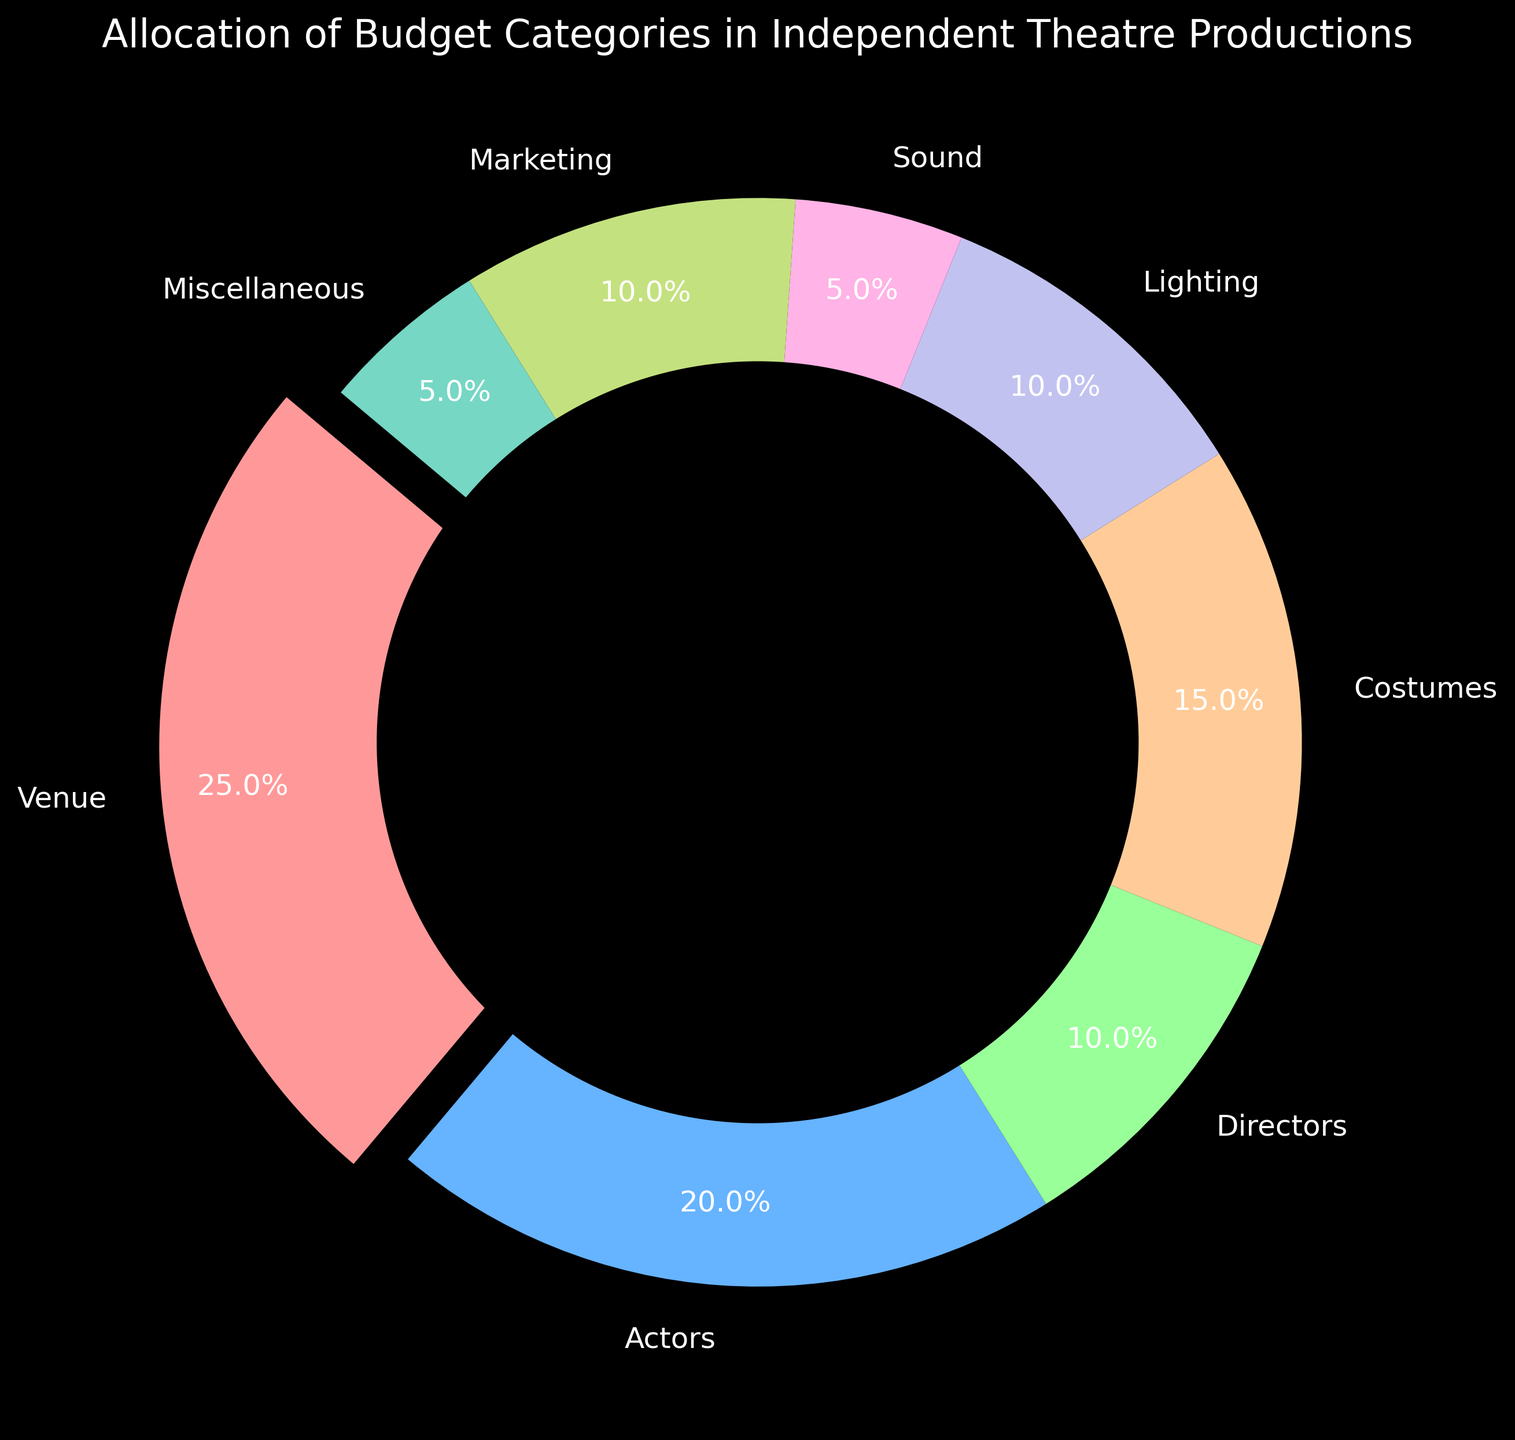What is the category with the largest budget allocation? The category with the largest budget allocation is visually emphasized by being slightly exploded out from the center. Looking at the chart, "Venue" is the most prominent category with 25%.
Answer: Venue Which two categories have a combined budget allocation of 30%? To find the combined budget allocation, sum the percentages of different categories. The categories "Directors" (10%) and "Marketing" (10%) together with "Sound" (5%) and "Miscellaneous" (5%) both total 30%.
Answer: Directors and Marketing; or Sound and Miscellaneous How does the budget allocation for Lighting compare to that for Costumes? Looking at the chart, "Lighting" has a 10% allocation, while "Costumes" has a 15% allocation.
Answer: Lighting has a smaller budget than Costumes How much more budget is allocated to Venue than Actors? The "Venue" category has 25%, while "Actors" has 20%. The difference is 25% - 20%.
Answer: 5% If you combine the budget for Lighting and Sound, does it exceed the budget for Costumes? Lighting has 10% and Sound has 5%, so combined, they total 15%. Costumes also have 15%. Therefore, the combined budget for Lighting and Sound equals that for Costumes.
Answer: No What is the average budget allocation for Actors, Costumes, and Marketing? To find the average, sum the allocations and divide by the number of categories. Actors: 20%, Costumes: 15%, Marketing: 10%. Sum is 45%. Divide by 3 to get the average (45% / 3).
Answer: 15% Which category has the smallest budget allocation, and what is its percentage? By visually identifying the smallest segment in the chart, the "Sound" and "Miscellaneous" categories are the smallest, both having 5% each.
Answer: Sound and Miscellaneous, 5% If the budget of Lighting was doubled, what would its new percentage be? Doubling the Lighting budget (currently 10%) would result in 10% * 2.
Answer: 20% What percentage of the budget is allocated to production-related categories (Venue, Costumes, Lighting, Sound)? Sum the percentages for production-related categories: Venue (25%), Costumes (15%), Lighting (10%), and Sound (5%). Sum is 25% + 15% + 10% + 5%.
Answer: 55% How many categories have a budget allocation greater than or equal to 10%? To determine this, count the categories with 10% or more. Venue (25%), Actors (20%), Costumes (15%), Directors (10%), and Marketing (10%), making a total of 5 categories.
Answer: 5 